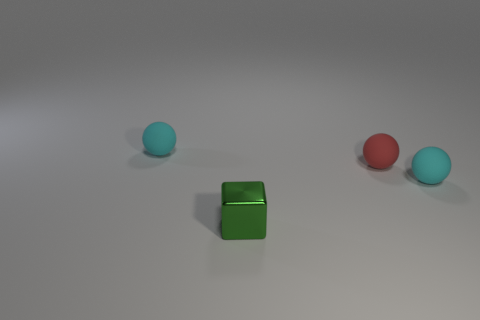Is there anything else that is the same shape as the red matte thing?
Your response must be concise. Yes. Are there more matte things to the right of the small shiny block than shiny cubes?
Your answer should be very brief. Yes. There is a small matte thing that is left of the green block; how many cyan matte balls are to the right of it?
Ensure brevity in your answer.  1. There is a tiny cyan thing left of the cyan object that is on the right side of the small ball on the left side of the metal thing; what shape is it?
Your response must be concise. Sphere. What is the size of the red rubber object?
Your answer should be very brief. Small. Are there any large blue cylinders that have the same material as the small red sphere?
Keep it short and to the point. No. Is the number of tiny rubber spheres right of the green thing the same as the number of small red balls?
Your answer should be very brief. No. There is a red rubber object that is to the right of the small green object; does it have the same shape as the tiny metallic thing?
Provide a short and direct response. No. The small red matte object is what shape?
Keep it short and to the point. Sphere. What material is the small red ball that is to the right of the small cyan rubber ball that is on the left side of the small matte ball in front of the red rubber sphere made of?
Offer a very short reply. Rubber. 